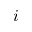<formula> <loc_0><loc_0><loc_500><loc_500>i</formula> 